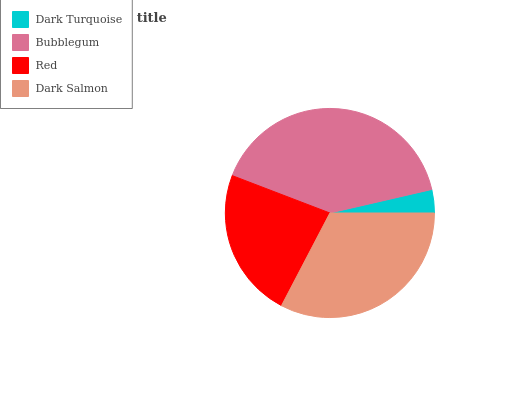Is Dark Turquoise the minimum?
Answer yes or no. Yes. Is Bubblegum the maximum?
Answer yes or no. Yes. Is Red the minimum?
Answer yes or no. No. Is Red the maximum?
Answer yes or no. No. Is Bubblegum greater than Red?
Answer yes or no. Yes. Is Red less than Bubblegum?
Answer yes or no. Yes. Is Red greater than Bubblegum?
Answer yes or no. No. Is Bubblegum less than Red?
Answer yes or no. No. Is Dark Salmon the high median?
Answer yes or no. Yes. Is Red the low median?
Answer yes or no. Yes. Is Dark Turquoise the high median?
Answer yes or no. No. Is Dark Turquoise the low median?
Answer yes or no. No. 